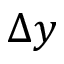Convert formula to latex. <formula><loc_0><loc_0><loc_500><loc_500>\Delta y</formula> 